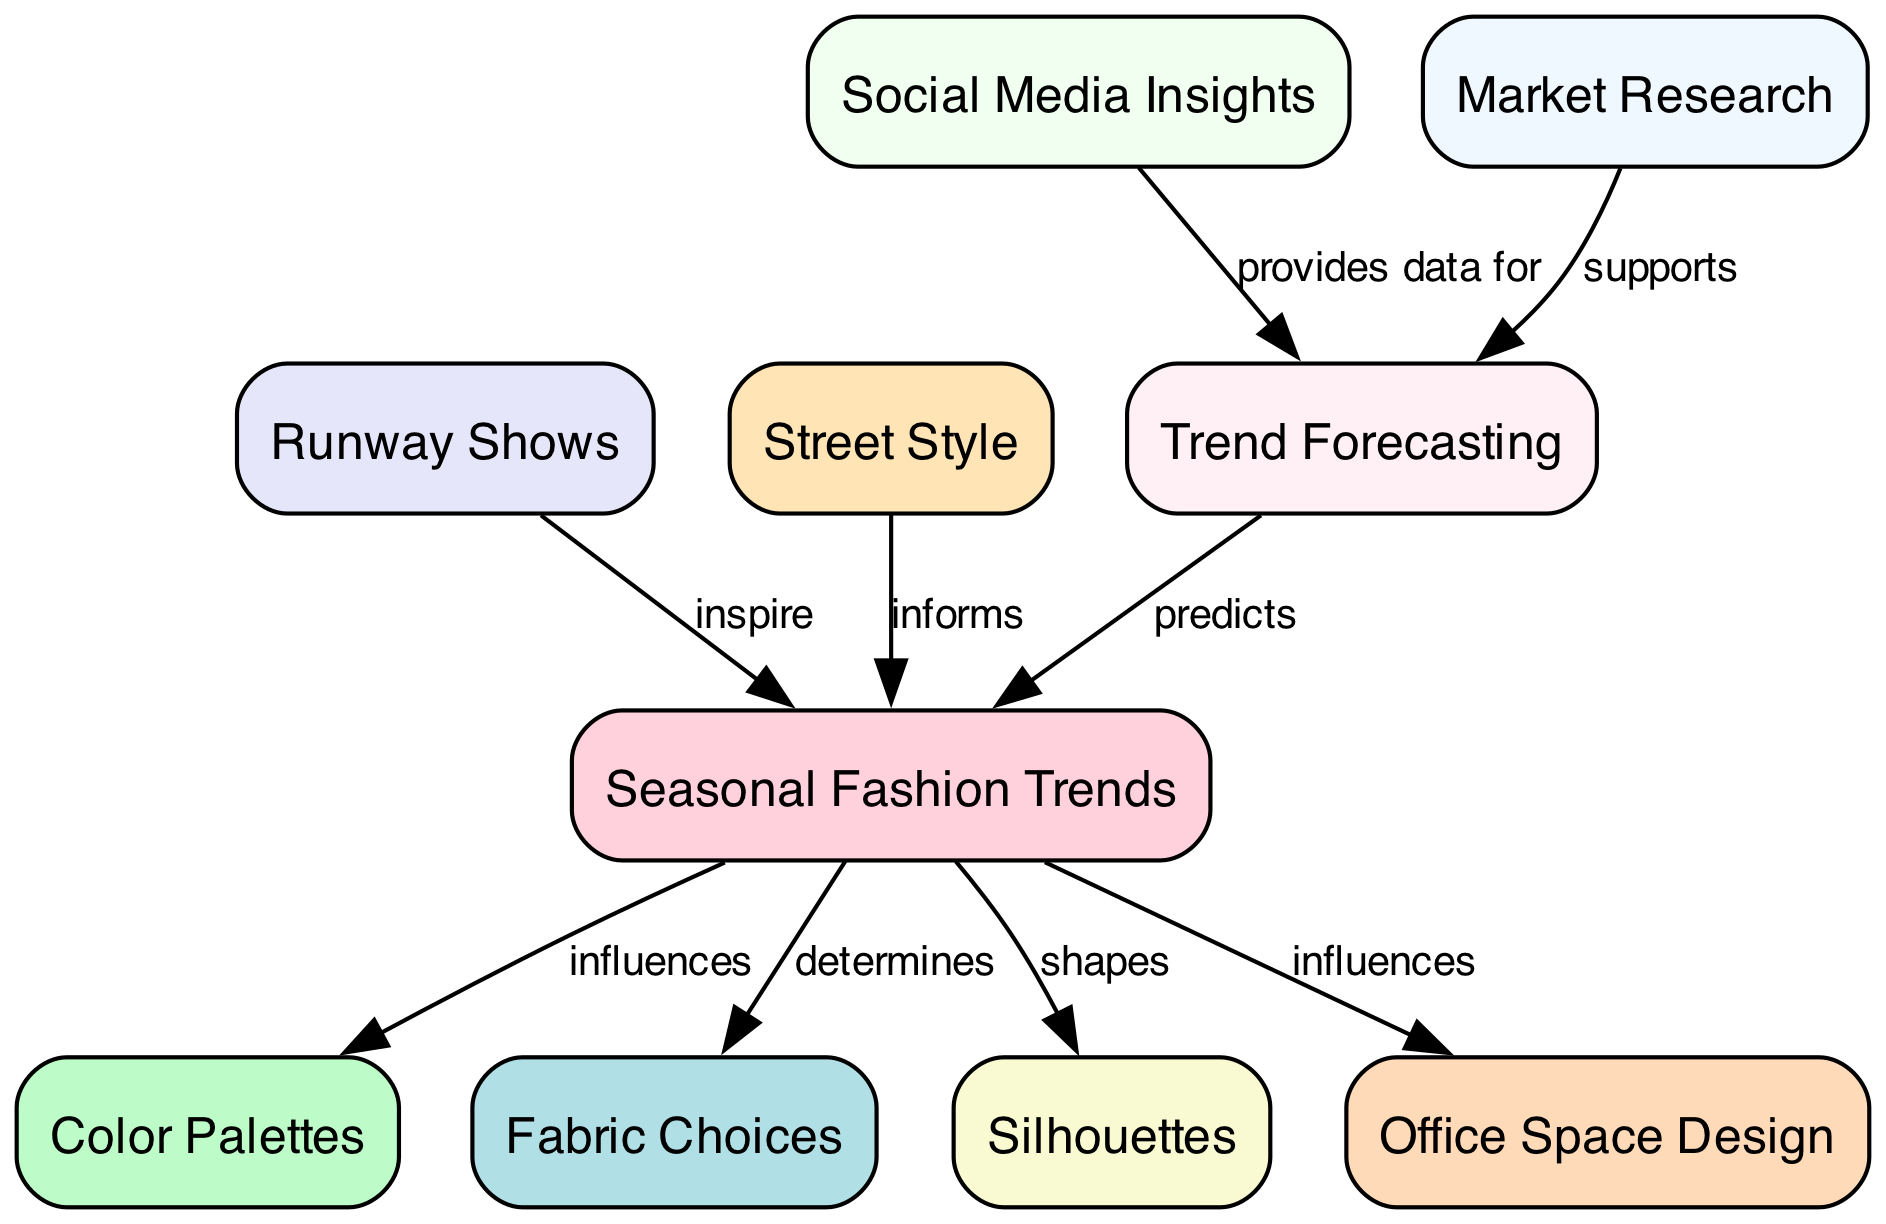What is the main focus of this concept map? The concept map centers around "Seasonal Fashion Trends," which serves as the primary node guiding the relationships depicted in the diagram.
Answer: Seasonal Fashion Trends How many nodes are present in the diagram? By counting all the listed nodes in the data, which include categories such as color palettes, fabric choices, and more, the total is determined to be ten.
Answer: 10 What does "Trend Forecasting" provide data for? According to the edges in the diagram, "Social Media Insights" is connected to "Trend Forecasting" as a source of data, suggesting that insights drawn from social media are instrumental in shaping trend predictions.
Answer: Social Media Insights Which node directly influences "Office Space Design"? In the diagram, there is an edge from "Seasonal Trends" to "Office Space Design," indicating that the trends in fashion directly impact how office spaces are designed.
Answer: Seasonal Trends How does "Market Research" relate to "Trend Forecasting"? The diagram shows that "Market Research" supports "Trend Forecasting," meaning that findings from market research play a critical role in informing and enhancing predictions of fashion trends.
Answer: Supports What are the two sources that inform "Seasonal Fashion Trends"? The connections indicating that "Runway Shows" inspire and "Street Style" informs "Seasonal Trends" suggest that both are key contributors to understanding and developing seasonal fashion direction.
Answer: Runway Shows, Street Style What role does "Trend Forecasting" play in relation to "Seasonal Trends"? The diagram specifies that "Trend Forecasting" predicts "Seasonal Trends," meaning that through forecasting methods, one can anticipate the nature of forthcoming fashion trends based on current data and patterns.
Answer: Predicts What influences "Fabric Choices"? The diagram indicates a direct relationship where "Seasonal Trends" determines "Fabric Choices," suggesting that the prevailing seasonal trends dictate what types of fabrics are chosen for collections.
Answer: Determines Which node is connected to "Seasonal Trends" through multiple relationships? "Seasonal Trends" is connected to "Color Palettes," "Fabric Choices," "Silhouettes," and "Office Space Design," showing that it interacts with various aspects of fashion and design, but predominantly, it connects to these four elements.
Answer: Color Palettes, Fabric Choices, Silhouettes, Office Space Design How does "Social Media" contribute to the diagram? "Social Media" is positioned to provide data for "Trend Forecasting," which underscores its significance in gathering insights that can project future trends in fashion.
Answer: Provides data for 